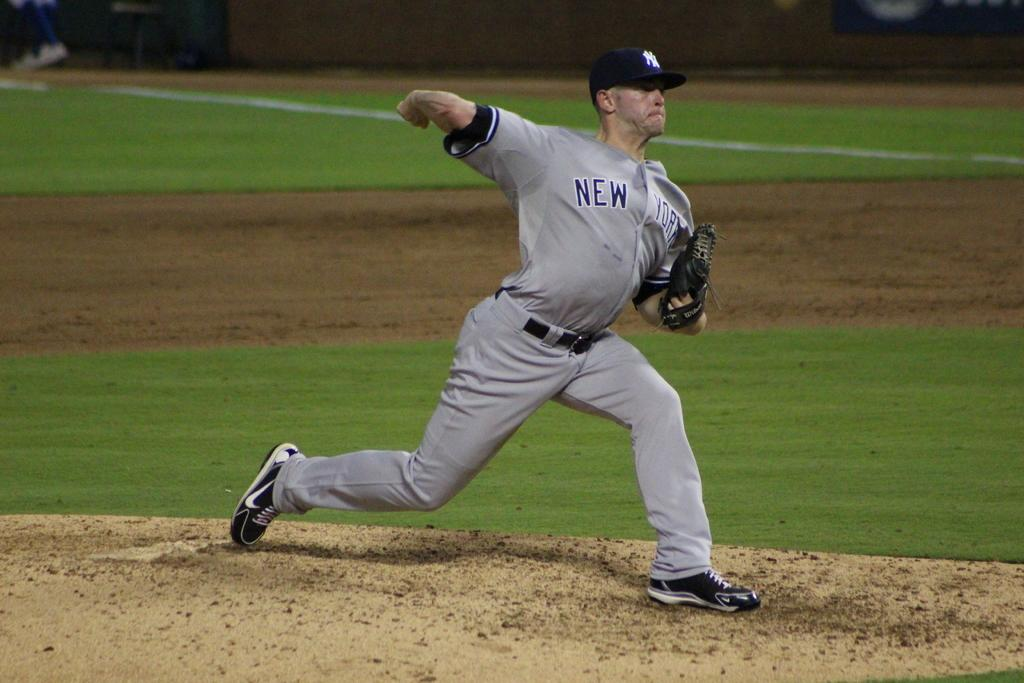<image>
Offer a succinct explanation of the picture presented. a player that has New York written on their jersey 